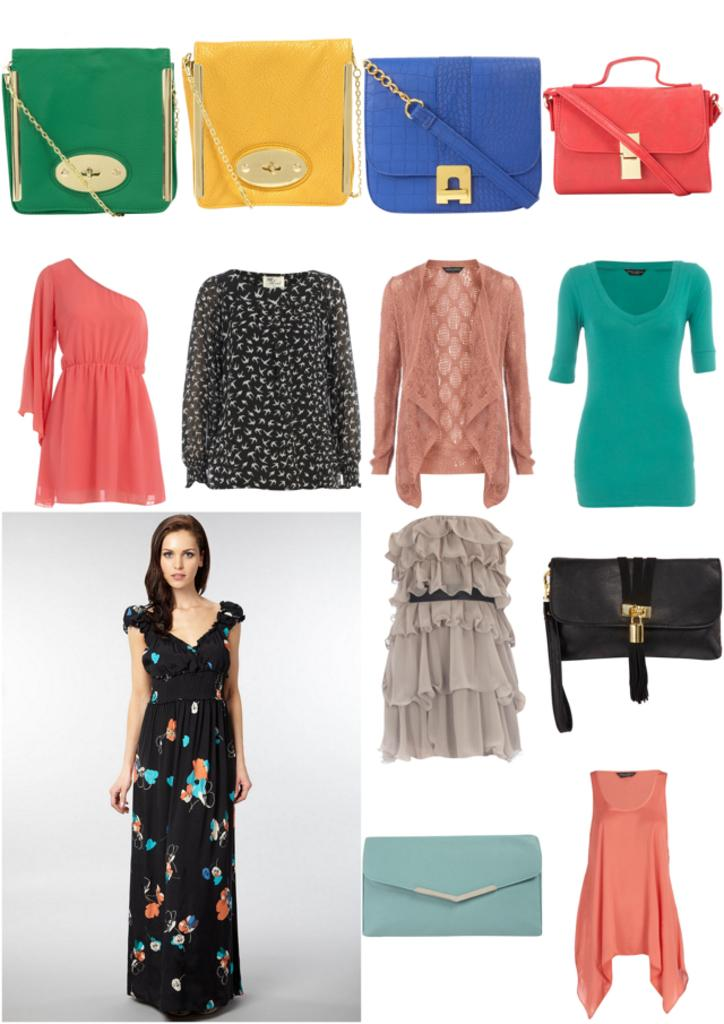Where is the woman located in the image? The woman is standing at the bottom left of the image. What items can be seen in the image besides the woman? There are clothes and handbags in the image. What type of vegetable is growing on the wall in the image? There is no wall or vegetable present in the image. 